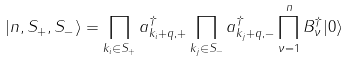<formula> <loc_0><loc_0><loc_500><loc_500>| n , S _ { + } , S _ { - } \rangle = \prod _ { k _ { i } \in S _ { + } } a _ { k _ { i } + q , + } ^ { \dag } \prod _ { k _ { j } \in S _ { - } } a _ { k _ { j } + q , - } ^ { \dag } \prod _ { \nu = 1 } ^ { n } B _ { \nu } ^ { \dag } | 0 \rangle</formula> 